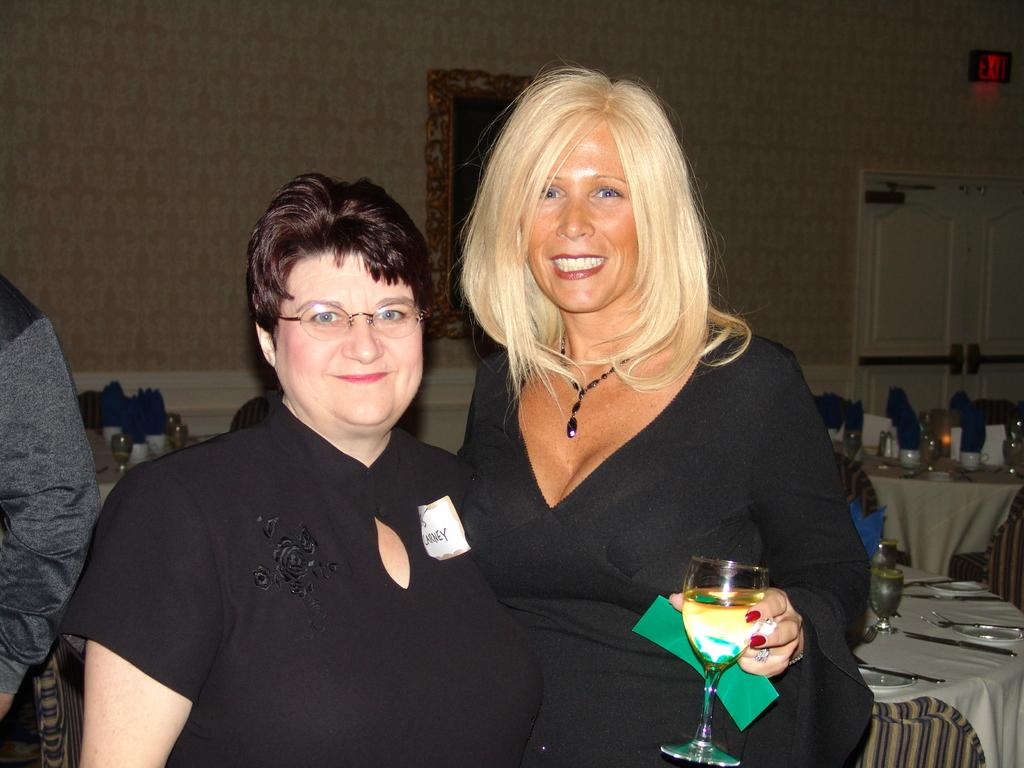How many people are present in the image? There are two persons standing in the image. What objects can be seen in the background? There is a table, a chair, a glass, a plate, a spoon, a door, and a frame attached to the wall in the background. Can you describe the person in the background? There is another person in the background, but no specific details are provided about their appearance or actions. What type of copy machine is visible in the image? There is no copy machine present in the image. What is the uncle of the person in the image doing? There is no information about an uncle or their actions in the image. 